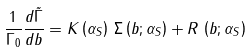Convert formula to latex. <formula><loc_0><loc_0><loc_500><loc_500>\frac { 1 } { \Gamma _ { 0 } } \frac { d \tilde { \Gamma } } { d b } = K \left ( \alpha _ { S } \right ) \, \Sigma \left ( b ; \alpha _ { S } \right ) + R \, \left ( b ; \alpha _ { S } \right )</formula> 